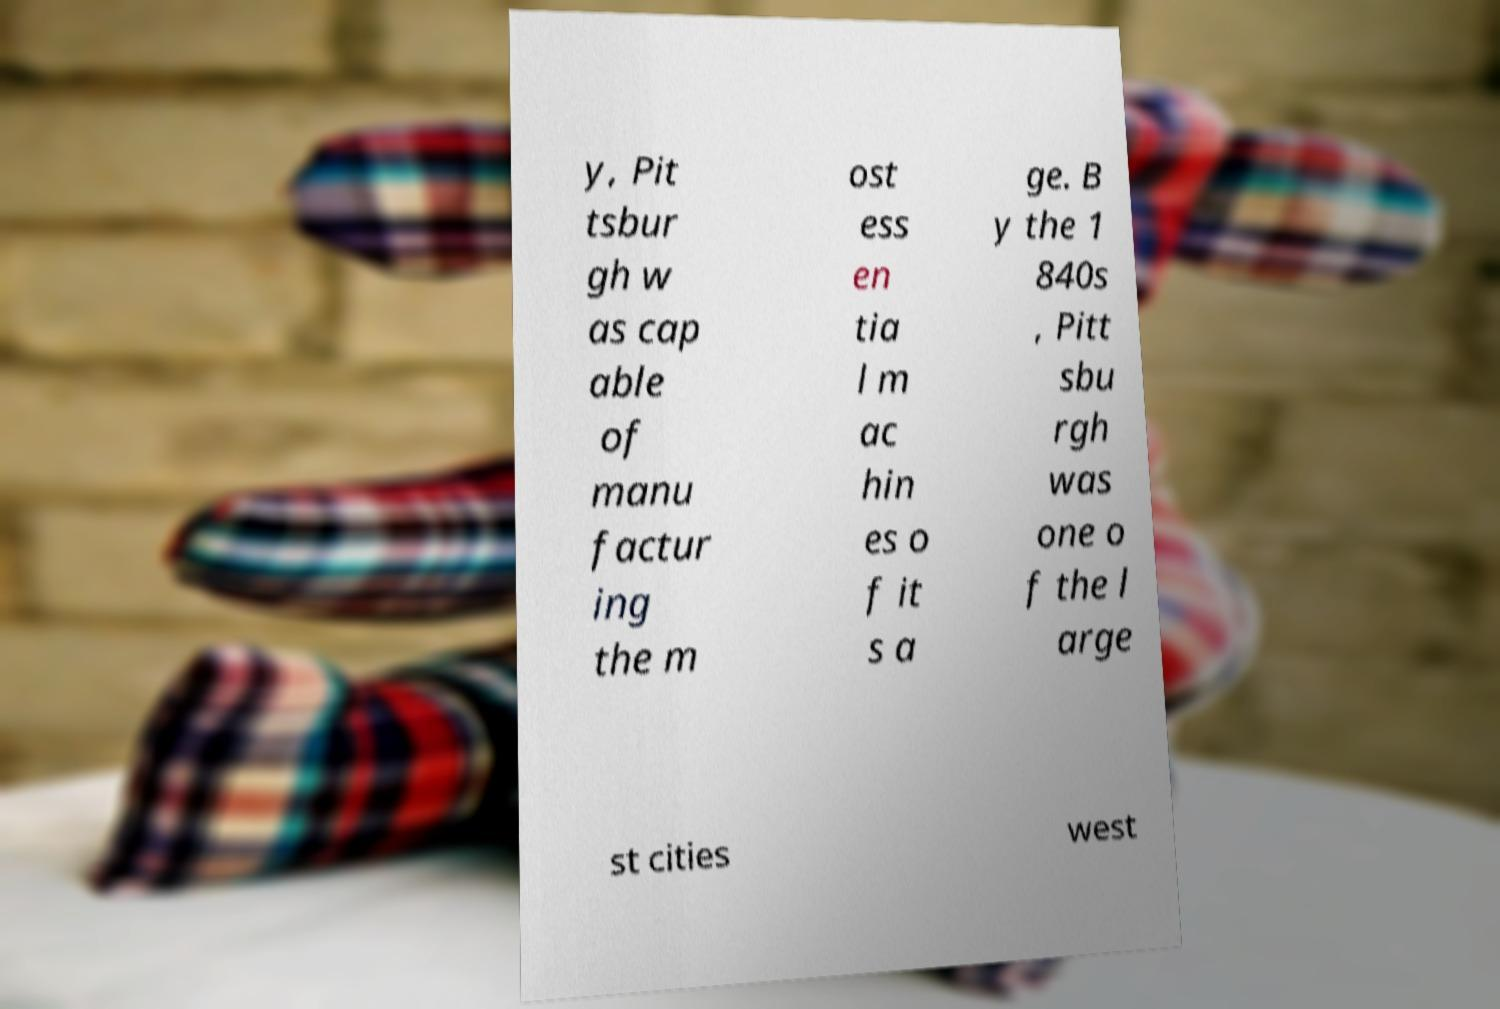Please identify and transcribe the text found in this image. y, Pit tsbur gh w as cap able of manu factur ing the m ost ess en tia l m ac hin es o f it s a ge. B y the 1 840s , Pitt sbu rgh was one o f the l arge st cities west 